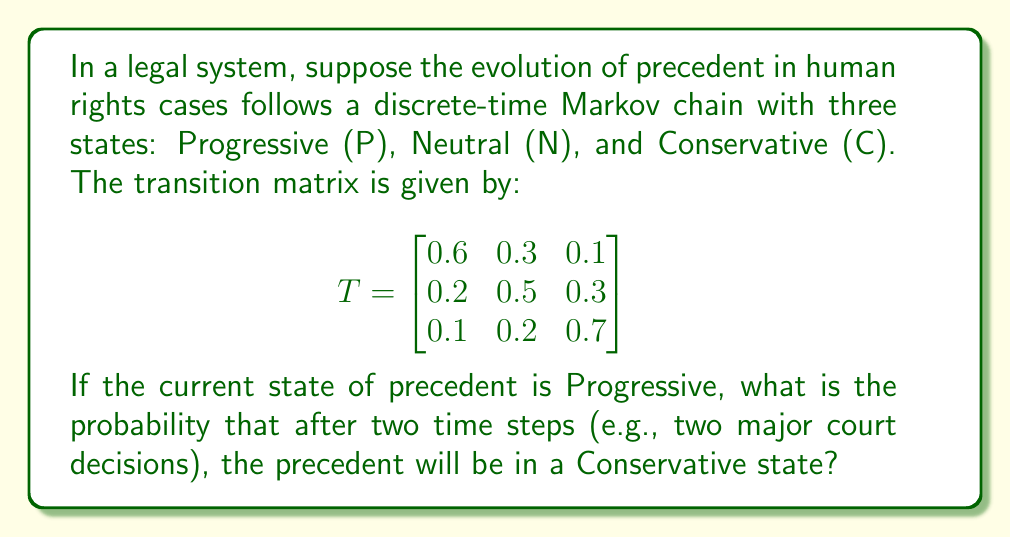Can you answer this question? To solve this problem, we need to use the properties of Markov chains and matrix multiplication. Let's approach this step-by-step:

1) The initial state vector is Progressive, so we start with:
   $v_0 = \begin{bmatrix} 1 \\ 0 \\ 0 \end{bmatrix}$

2) To find the state after two time steps, we need to multiply the transition matrix by itself and then by the initial state vector:
   $v_2 = T^2 \cdot v_0$

3) Let's calculate $T^2$:
   $$ T^2 = \begin{bmatrix}
   0.6 & 0.3 & 0.1 \\
   0.2 & 0.5 & 0.3 \\
   0.1 & 0.2 & 0.7
   \end{bmatrix} \cdot 
   \begin{bmatrix}
   0.6 & 0.3 & 0.1 \\
   0.2 & 0.5 & 0.3 \\
   0.1 & 0.2 & 0.7
   \end{bmatrix} $$

4) Performing the matrix multiplication:
   $$ T^2 = \begin{bmatrix}
   0.42 & 0.33 & 0.25 \\
   0.23 & 0.37 & 0.40 \\
   0.17 & 0.26 & 0.57
   \end{bmatrix} $$

5) Now, we multiply $T^2$ by $v_0$:
   $$ v_2 = \begin{bmatrix}
   0.42 & 0.33 & 0.25 \\
   0.23 & 0.37 & 0.40 \\
   0.17 & 0.26 & 0.57
   \end{bmatrix} \cdot 
   \begin{bmatrix}
   1 \\ 0 \\ 0
   \end{bmatrix} $$

6) This gives us:
   $$ v_2 = \begin{bmatrix}
   0.42 \\ 0.23 \\ 0.17
   \end{bmatrix} $$

7) The probability of being in the Conservative state (the third element of the vector) after two time steps is 0.17 or 17%.
Answer: 0.17 